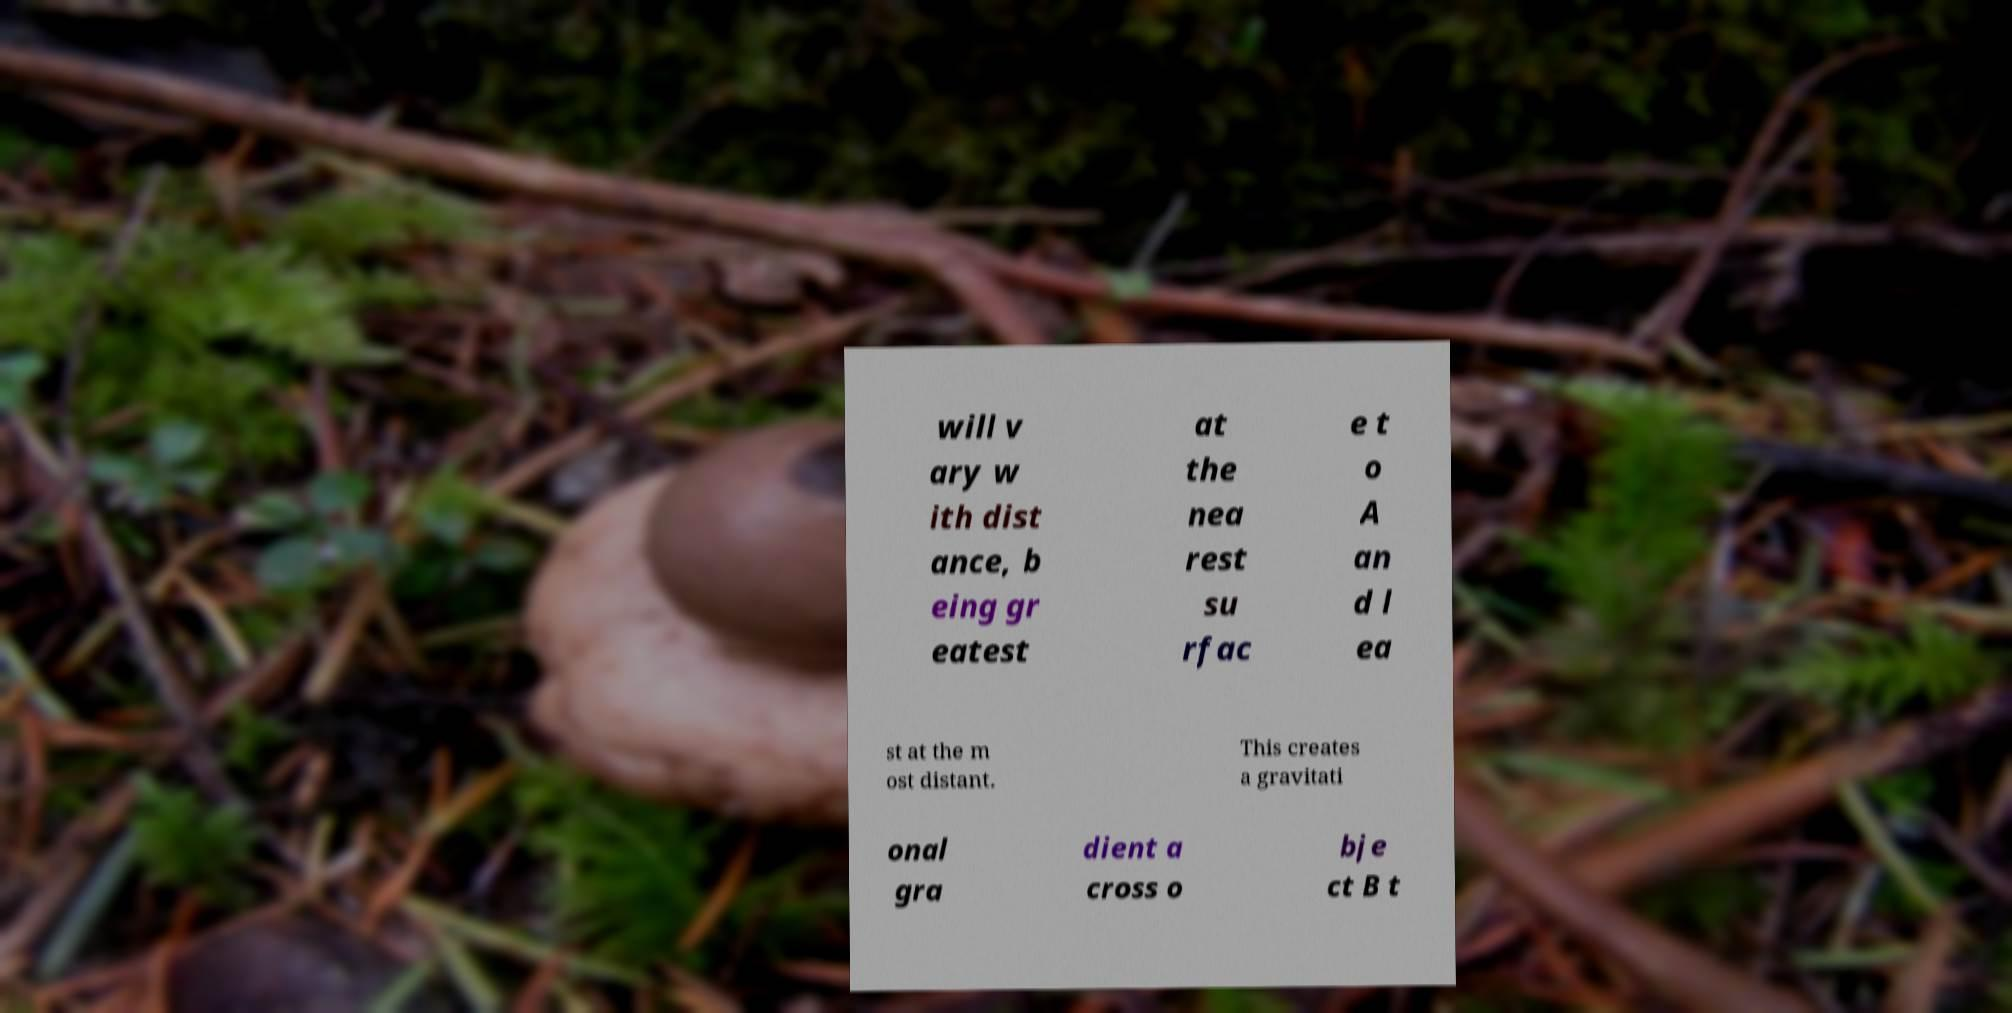What messages or text are displayed in this image? I need them in a readable, typed format. will v ary w ith dist ance, b eing gr eatest at the nea rest su rfac e t o A an d l ea st at the m ost distant. This creates a gravitati onal gra dient a cross o bje ct B t 